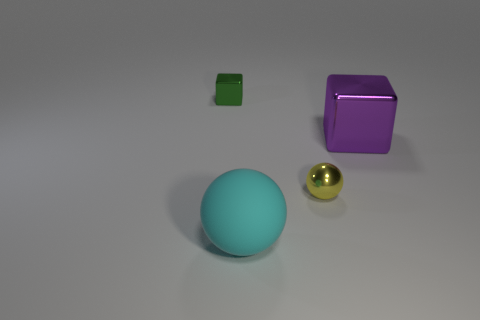Add 1 metallic blocks. How many objects exist? 5 Subtract all green metal balls. Subtract all yellow things. How many objects are left? 3 Add 3 yellow things. How many yellow things are left? 4 Add 3 yellow metal things. How many yellow metal things exist? 4 Subtract 0 brown cubes. How many objects are left? 4 